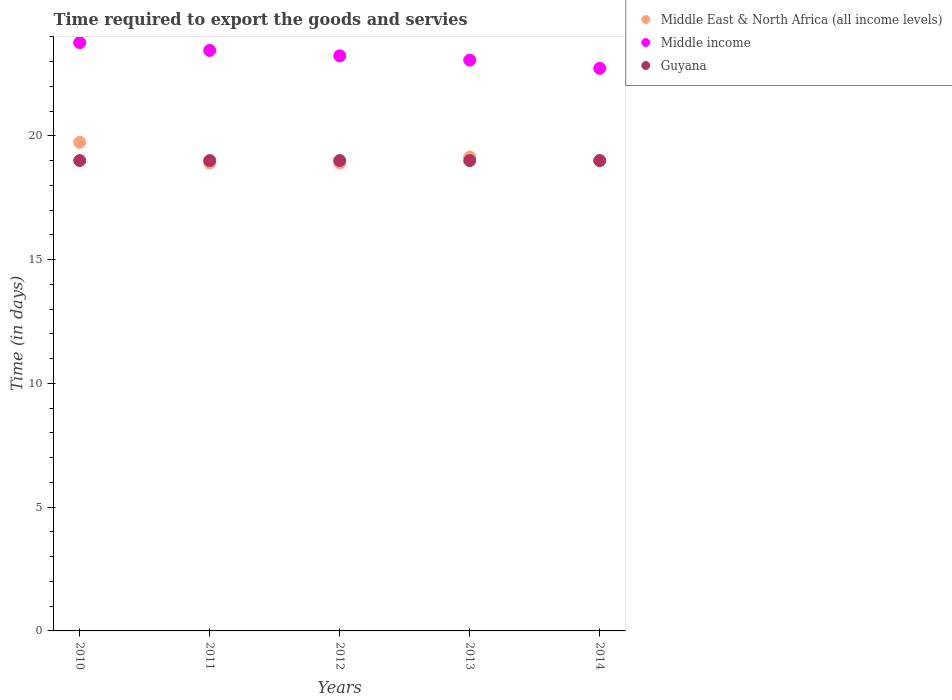How many different coloured dotlines are there?
Offer a terse response. 3. Is the number of dotlines equal to the number of legend labels?
Your response must be concise. Yes. What is the number of days required to export the goods and services in Middle income in 2013?
Make the answer very short. 23.06. Across all years, what is the maximum number of days required to export the goods and services in Middle East & North Africa (all income levels)?
Provide a short and direct response. 19.74. Across all years, what is the minimum number of days required to export the goods and services in Middle income?
Your response must be concise. 22.72. In which year was the number of days required to export the goods and services in Middle income maximum?
Provide a short and direct response. 2010. In which year was the number of days required to export the goods and services in Middle income minimum?
Your answer should be compact. 2014. What is the total number of days required to export the goods and services in Guyana in the graph?
Give a very brief answer. 95. What is the difference between the number of days required to export the goods and services in Guyana in 2013 and that in 2014?
Provide a short and direct response. 0. What is the difference between the number of days required to export the goods and services in Guyana in 2011 and the number of days required to export the goods and services in Middle East & North Africa (all income levels) in 2014?
Keep it short and to the point. 0. What is the average number of days required to export the goods and services in Middle East & North Africa (all income levels) per year?
Keep it short and to the point. 19.14. In the year 2011, what is the difference between the number of days required to export the goods and services in Middle East & North Africa (all income levels) and number of days required to export the goods and services in Guyana?
Your answer should be very brief. -0.1. What is the ratio of the number of days required to export the goods and services in Guyana in 2013 to that in 2014?
Provide a short and direct response. 1. Is the difference between the number of days required to export the goods and services in Middle East & North Africa (all income levels) in 2013 and 2014 greater than the difference between the number of days required to export the goods and services in Guyana in 2013 and 2014?
Keep it short and to the point. Yes. What is the difference between the highest and the second highest number of days required to export the goods and services in Middle income?
Provide a succinct answer. 0.32. What is the difference between the highest and the lowest number of days required to export the goods and services in Middle East & North Africa (all income levels)?
Provide a short and direct response. 0.84. Is the sum of the number of days required to export the goods and services in Middle income in 2011 and 2013 greater than the maximum number of days required to export the goods and services in Guyana across all years?
Offer a very short reply. Yes. How many years are there in the graph?
Provide a succinct answer. 5. Are the values on the major ticks of Y-axis written in scientific E-notation?
Make the answer very short. No. Does the graph contain grids?
Your answer should be very brief. No. Where does the legend appear in the graph?
Keep it short and to the point. Top right. What is the title of the graph?
Give a very brief answer. Time required to export the goods and servies. What is the label or title of the Y-axis?
Give a very brief answer. Time (in days). What is the Time (in days) of Middle East & North Africa (all income levels) in 2010?
Give a very brief answer. 19.74. What is the Time (in days) of Middle income in 2010?
Offer a terse response. 23.77. What is the Time (in days) in Guyana in 2010?
Make the answer very short. 19. What is the Time (in days) of Middle income in 2011?
Offer a very short reply. 23.45. What is the Time (in days) in Middle East & North Africa (all income levels) in 2012?
Provide a short and direct response. 18.9. What is the Time (in days) of Middle income in 2012?
Your answer should be compact. 23.23. What is the Time (in days) of Guyana in 2012?
Make the answer very short. 19. What is the Time (in days) of Middle East & North Africa (all income levels) in 2013?
Your response must be concise. 19.14. What is the Time (in days) in Middle income in 2013?
Offer a very short reply. 23.06. What is the Time (in days) in Middle East & North Africa (all income levels) in 2014?
Your answer should be compact. 19. What is the Time (in days) of Middle income in 2014?
Your response must be concise. 22.72. What is the Time (in days) of Guyana in 2014?
Keep it short and to the point. 19. Across all years, what is the maximum Time (in days) of Middle East & North Africa (all income levels)?
Your response must be concise. 19.74. Across all years, what is the maximum Time (in days) in Middle income?
Provide a short and direct response. 23.77. Across all years, what is the minimum Time (in days) of Middle East & North Africa (all income levels)?
Make the answer very short. 18.9. Across all years, what is the minimum Time (in days) of Middle income?
Give a very brief answer. 22.72. What is the total Time (in days) in Middle East & North Africa (all income levels) in the graph?
Make the answer very short. 95.68. What is the total Time (in days) of Middle income in the graph?
Offer a terse response. 116.23. What is the difference between the Time (in days) of Middle East & North Africa (all income levels) in 2010 and that in 2011?
Provide a succinct answer. 0.84. What is the difference between the Time (in days) of Middle income in 2010 and that in 2011?
Provide a succinct answer. 0.32. What is the difference between the Time (in days) of Guyana in 2010 and that in 2011?
Provide a succinct answer. 0. What is the difference between the Time (in days) in Middle East & North Africa (all income levels) in 2010 and that in 2012?
Keep it short and to the point. 0.83. What is the difference between the Time (in days) of Middle income in 2010 and that in 2012?
Your answer should be very brief. 0.54. What is the difference between the Time (in days) of Guyana in 2010 and that in 2012?
Give a very brief answer. 0. What is the difference between the Time (in days) of Middle East & North Africa (all income levels) in 2010 and that in 2013?
Give a very brief answer. 0.59. What is the difference between the Time (in days) in Middle income in 2010 and that in 2013?
Provide a succinct answer. 0.71. What is the difference between the Time (in days) of Guyana in 2010 and that in 2013?
Keep it short and to the point. 0. What is the difference between the Time (in days) in Middle East & North Africa (all income levels) in 2010 and that in 2014?
Your response must be concise. 0.74. What is the difference between the Time (in days) in Middle income in 2010 and that in 2014?
Ensure brevity in your answer.  1.04. What is the difference between the Time (in days) in Guyana in 2010 and that in 2014?
Your answer should be compact. 0. What is the difference between the Time (in days) of Middle East & North Africa (all income levels) in 2011 and that in 2012?
Make the answer very short. -0. What is the difference between the Time (in days) of Middle income in 2011 and that in 2012?
Provide a short and direct response. 0.22. What is the difference between the Time (in days) in Guyana in 2011 and that in 2012?
Your answer should be very brief. 0. What is the difference between the Time (in days) in Middle East & North Africa (all income levels) in 2011 and that in 2013?
Your answer should be very brief. -0.24. What is the difference between the Time (in days) of Middle income in 2011 and that in 2013?
Provide a succinct answer. 0.39. What is the difference between the Time (in days) of Guyana in 2011 and that in 2013?
Provide a short and direct response. 0. What is the difference between the Time (in days) in Middle East & North Africa (all income levels) in 2011 and that in 2014?
Provide a succinct answer. -0.1. What is the difference between the Time (in days) in Middle income in 2011 and that in 2014?
Your answer should be compact. 0.72. What is the difference between the Time (in days) of Guyana in 2011 and that in 2014?
Ensure brevity in your answer.  0. What is the difference between the Time (in days) of Middle East & North Africa (all income levels) in 2012 and that in 2013?
Make the answer very short. -0.24. What is the difference between the Time (in days) in Middle income in 2012 and that in 2013?
Your answer should be very brief. 0.17. What is the difference between the Time (in days) of Guyana in 2012 and that in 2013?
Keep it short and to the point. 0. What is the difference between the Time (in days) in Middle East & North Africa (all income levels) in 2012 and that in 2014?
Your response must be concise. -0.1. What is the difference between the Time (in days) in Middle income in 2012 and that in 2014?
Your answer should be compact. 0.51. What is the difference between the Time (in days) in Guyana in 2012 and that in 2014?
Your response must be concise. 0. What is the difference between the Time (in days) in Middle East & North Africa (all income levels) in 2013 and that in 2014?
Provide a short and direct response. 0.14. What is the difference between the Time (in days) in Middle income in 2013 and that in 2014?
Provide a succinct answer. 0.33. What is the difference between the Time (in days) of Guyana in 2013 and that in 2014?
Your answer should be compact. 0. What is the difference between the Time (in days) in Middle East & North Africa (all income levels) in 2010 and the Time (in days) in Middle income in 2011?
Keep it short and to the point. -3.71. What is the difference between the Time (in days) of Middle East & North Africa (all income levels) in 2010 and the Time (in days) of Guyana in 2011?
Give a very brief answer. 0.74. What is the difference between the Time (in days) in Middle income in 2010 and the Time (in days) in Guyana in 2011?
Keep it short and to the point. 4.77. What is the difference between the Time (in days) in Middle East & North Africa (all income levels) in 2010 and the Time (in days) in Middle income in 2012?
Your answer should be compact. -3.49. What is the difference between the Time (in days) in Middle East & North Africa (all income levels) in 2010 and the Time (in days) in Guyana in 2012?
Keep it short and to the point. 0.74. What is the difference between the Time (in days) of Middle income in 2010 and the Time (in days) of Guyana in 2012?
Keep it short and to the point. 4.77. What is the difference between the Time (in days) of Middle East & North Africa (all income levels) in 2010 and the Time (in days) of Middle income in 2013?
Give a very brief answer. -3.32. What is the difference between the Time (in days) of Middle East & North Africa (all income levels) in 2010 and the Time (in days) of Guyana in 2013?
Your response must be concise. 0.74. What is the difference between the Time (in days) of Middle income in 2010 and the Time (in days) of Guyana in 2013?
Your answer should be compact. 4.77. What is the difference between the Time (in days) in Middle East & North Africa (all income levels) in 2010 and the Time (in days) in Middle income in 2014?
Keep it short and to the point. -2.99. What is the difference between the Time (in days) of Middle East & North Africa (all income levels) in 2010 and the Time (in days) of Guyana in 2014?
Your response must be concise. 0.74. What is the difference between the Time (in days) in Middle income in 2010 and the Time (in days) in Guyana in 2014?
Provide a short and direct response. 4.77. What is the difference between the Time (in days) of Middle East & North Africa (all income levels) in 2011 and the Time (in days) of Middle income in 2012?
Offer a terse response. -4.33. What is the difference between the Time (in days) in Middle East & North Africa (all income levels) in 2011 and the Time (in days) in Guyana in 2012?
Give a very brief answer. -0.1. What is the difference between the Time (in days) in Middle income in 2011 and the Time (in days) in Guyana in 2012?
Your response must be concise. 4.45. What is the difference between the Time (in days) in Middle East & North Africa (all income levels) in 2011 and the Time (in days) in Middle income in 2013?
Offer a terse response. -4.16. What is the difference between the Time (in days) in Middle income in 2011 and the Time (in days) in Guyana in 2013?
Keep it short and to the point. 4.45. What is the difference between the Time (in days) of Middle East & North Africa (all income levels) in 2011 and the Time (in days) of Middle income in 2014?
Offer a terse response. -3.82. What is the difference between the Time (in days) in Middle East & North Africa (all income levels) in 2011 and the Time (in days) in Guyana in 2014?
Ensure brevity in your answer.  -0.1. What is the difference between the Time (in days) of Middle income in 2011 and the Time (in days) of Guyana in 2014?
Provide a succinct answer. 4.45. What is the difference between the Time (in days) of Middle East & North Africa (all income levels) in 2012 and the Time (in days) of Middle income in 2013?
Provide a short and direct response. -4.15. What is the difference between the Time (in days) in Middle East & North Africa (all income levels) in 2012 and the Time (in days) in Guyana in 2013?
Your answer should be very brief. -0.1. What is the difference between the Time (in days) in Middle income in 2012 and the Time (in days) in Guyana in 2013?
Keep it short and to the point. 4.23. What is the difference between the Time (in days) in Middle East & North Africa (all income levels) in 2012 and the Time (in days) in Middle income in 2014?
Your answer should be compact. -3.82. What is the difference between the Time (in days) in Middle East & North Africa (all income levels) in 2012 and the Time (in days) in Guyana in 2014?
Your answer should be compact. -0.1. What is the difference between the Time (in days) in Middle income in 2012 and the Time (in days) in Guyana in 2014?
Provide a succinct answer. 4.23. What is the difference between the Time (in days) in Middle East & North Africa (all income levels) in 2013 and the Time (in days) in Middle income in 2014?
Your answer should be very brief. -3.58. What is the difference between the Time (in days) of Middle East & North Africa (all income levels) in 2013 and the Time (in days) of Guyana in 2014?
Your response must be concise. 0.14. What is the difference between the Time (in days) of Middle income in 2013 and the Time (in days) of Guyana in 2014?
Ensure brevity in your answer.  4.06. What is the average Time (in days) in Middle East & North Africa (all income levels) per year?
Your answer should be compact. 19.14. What is the average Time (in days) in Middle income per year?
Ensure brevity in your answer.  23.25. In the year 2010, what is the difference between the Time (in days) in Middle East & North Africa (all income levels) and Time (in days) in Middle income?
Your answer should be very brief. -4.03. In the year 2010, what is the difference between the Time (in days) of Middle East & North Africa (all income levels) and Time (in days) of Guyana?
Make the answer very short. 0.74. In the year 2010, what is the difference between the Time (in days) in Middle income and Time (in days) in Guyana?
Keep it short and to the point. 4.77. In the year 2011, what is the difference between the Time (in days) of Middle East & North Africa (all income levels) and Time (in days) of Middle income?
Make the answer very short. -4.55. In the year 2011, what is the difference between the Time (in days) in Middle East & North Africa (all income levels) and Time (in days) in Guyana?
Your answer should be compact. -0.1. In the year 2011, what is the difference between the Time (in days) of Middle income and Time (in days) of Guyana?
Your answer should be compact. 4.45. In the year 2012, what is the difference between the Time (in days) in Middle East & North Africa (all income levels) and Time (in days) in Middle income?
Ensure brevity in your answer.  -4.33. In the year 2012, what is the difference between the Time (in days) in Middle East & North Africa (all income levels) and Time (in days) in Guyana?
Keep it short and to the point. -0.1. In the year 2012, what is the difference between the Time (in days) of Middle income and Time (in days) of Guyana?
Your answer should be compact. 4.23. In the year 2013, what is the difference between the Time (in days) of Middle East & North Africa (all income levels) and Time (in days) of Middle income?
Your response must be concise. -3.91. In the year 2013, what is the difference between the Time (in days) in Middle East & North Africa (all income levels) and Time (in days) in Guyana?
Your answer should be compact. 0.14. In the year 2013, what is the difference between the Time (in days) in Middle income and Time (in days) in Guyana?
Keep it short and to the point. 4.06. In the year 2014, what is the difference between the Time (in days) of Middle East & North Africa (all income levels) and Time (in days) of Middle income?
Your answer should be compact. -3.72. In the year 2014, what is the difference between the Time (in days) of Middle East & North Africa (all income levels) and Time (in days) of Guyana?
Ensure brevity in your answer.  0. In the year 2014, what is the difference between the Time (in days) of Middle income and Time (in days) of Guyana?
Offer a very short reply. 3.72. What is the ratio of the Time (in days) in Middle East & North Africa (all income levels) in 2010 to that in 2011?
Make the answer very short. 1.04. What is the ratio of the Time (in days) of Middle income in 2010 to that in 2011?
Make the answer very short. 1.01. What is the ratio of the Time (in days) in Middle East & North Africa (all income levels) in 2010 to that in 2012?
Your answer should be compact. 1.04. What is the ratio of the Time (in days) in Middle income in 2010 to that in 2012?
Offer a terse response. 1.02. What is the ratio of the Time (in days) of Guyana in 2010 to that in 2012?
Give a very brief answer. 1. What is the ratio of the Time (in days) in Middle East & North Africa (all income levels) in 2010 to that in 2013?
Ensure brevity in your answer.  1.03. What is the ratio of the Time (in days) in Middle income in 2010 to that in 2013?
Ensure brevity in your answer.  1.03. What is the ratio of the Time (in days) in Middle East & North Africa (all income levels) in 2010 to that in 2014?
Provide a succinct answer. 1.04. What is the ratio of the Time (in days) of Middle income in 2010 to that in 2014?
Ensure brevity in your answer.  1.05. What is the ratio of the Time (in days) in Guyana in 2010 to that in 2014?
Keep it short and to the point. 1. What is the ratio of the Time (in days) of Middle income in 2011 to that in 2012?
Give a very brief answer. 1.01. What is the ratio of the Time (in days) of Guyana in 2011 to that in 2012?
Offer a very short reply. 1. What is the ratio of the Time (in days) of Middle East & North Africa (all income levels) in 2011 to that in 2013?
Provide a short and direct response. 0.99. What is the ratio of the Time (in days) of Guyana in 2011 to that in 2013?
Make the answer very short. 1. What is the ratio of the Time (in days) of Middle East & North Africa (all income levels) in 2011 to that in 2014?
Ensure brevity in your answer.  0.99. What is the ratio of the Time (in days) of Middle income in 2011 to that in 2014?
Offer a very short reply. 1.03. What is the ratio of the Time (in days) in Middle East & North Africa (all income levels) in 2012 to that in 2013?
Offer a terse response. 0.99. What is the ratio of the Time (in days) of Middle income in 2012 to that in 2013?
Offer a very short reply. 1.01. What is the ratio of the Time (in days) in Guyana in 2012 to that in 2013?
Your answer should be very brief. 1. What is the ratio of the Time (in days) of Middle income in 2012 to that in 2014?
Offer a terse response. 1.02. What is the ratio of the Time (in days) in Middle East & North Africa (all income levels) in 2013 to that in 2014?
Your answer should be very brief. 1.01. What is the ratio of the Time (in days) of Middle income in 2013 to that in 2014?
Provide a succinct answer. 1.01. What is the ratio of the Time (in days) of Guyana in 2013 to that in 2014?
Your answer should be very brief. 1. What is the difference between the highest and the second highest Time (in days) in Middle East & North Africa (all income levels)?
Your answer should be compact. 0.59. What is the difference between the highest and the second highest Time (in days) in Middle income?
Your response must be concise. 0.32. What is the difference between the highest and the lowest Time (in days) in Middle East & North Africa (all income levels)?
Give a very brief answer. 0.84. What is the difference between the highest and the lowest Time (in days) in Middle income?
Keep it short and to the point. 1.04. What is the difference between the highest and the lowest Time (in days) in Guyana?
Give a very brief answer. 0. 